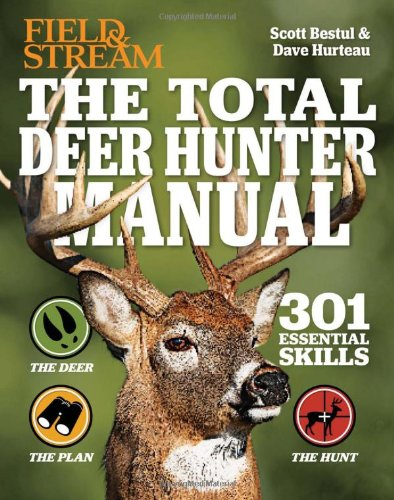Are there any advanced techniques covered in this manual that might benefit experienced hunters? Certainly, the book advances into complex hunting strategies and techniques, such as effective use of calls and decoys, precision shooting tips, and expert advice on handling various environmental conditions. What about safety tips? Does it include guidelines on hunting safety? Absolutely, it emphasizes safety with guidelines on proper use of hunting equipment, ethical hunting practices, and how to handle emergency situations in the wild. 